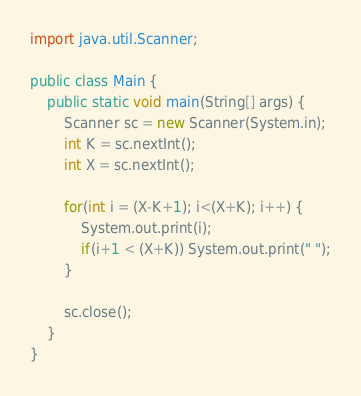Convert code to text. <code><loc_0><loc_0><loc_500><loc_500><_Java_>import java.util.Scanner;

public class Main {
	public static void main(String[] args) {
		Scanner sc = new Scanner(System.in);
		int K = sc.nextInt();
		int X = sc.nextInt();

		for(int i = (X-K+1); i<(X+K); i++) {
			System.out.print(i);
			if(i+1 < (X+K)) System.out.print(" ");
		}

		sc.close();
	}
}
</code> 